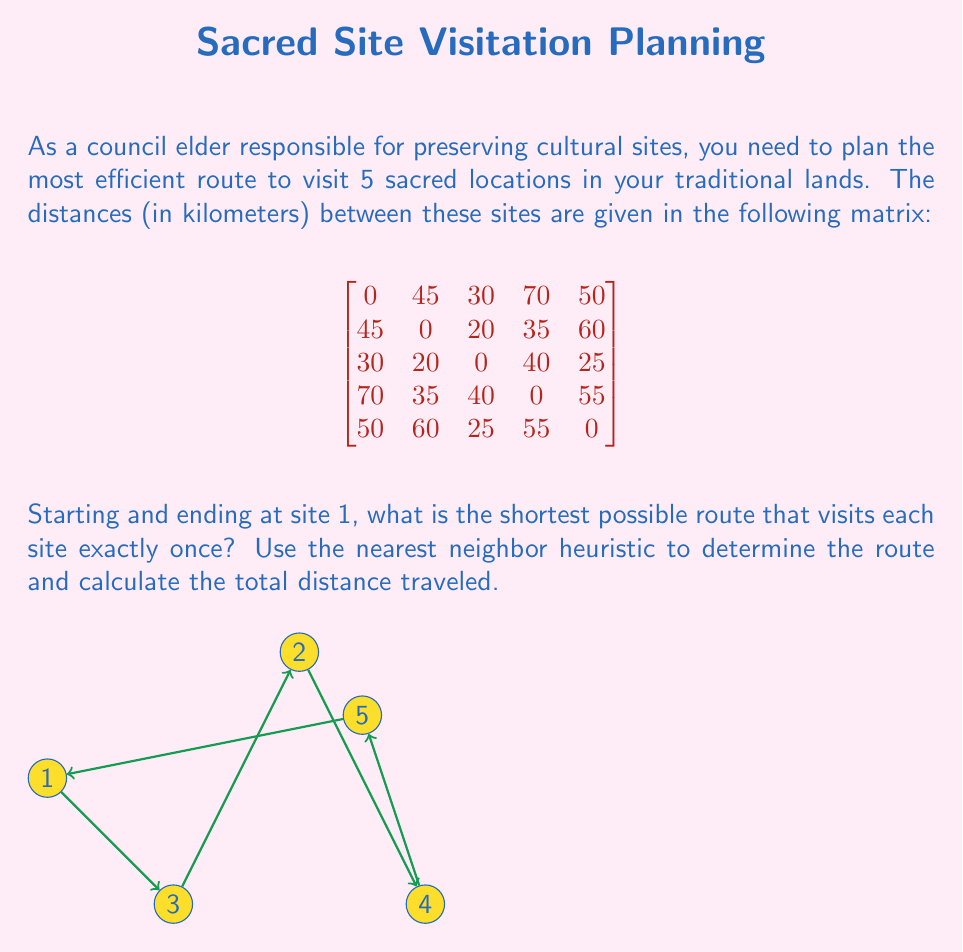Help me with this question. Let's solve this problem using the nearest neighbor heuristic:

1) Start at site 1.

2) Find the nearest unvisited site:
   - From site 1, the nearest is site 3 (30 km).

3) Move to site 3 and repeat:
   - From site 3, the nearest unvisited site is site 2 (20 km).

4) Move to site 2 and repeat:
   - From site 2, the nearest unvisited site is site 4 (35 km).

5) Move to site 4 and repeat:
   - From site 4, the only unvisited site is site 5 (55 km).

6) Move to site 5.

7) Return to site 1 (50 km).

The route is: 1 → 3 → 2 → 4 → 5 → 1

Calculate the total distance:
$$ \text{Total Distance} = 30 + 20 + 35 + 55 + 50 = 190 \text{ km} $$

Note: This heuristic doesn't guarantee the optimal solution, but it provides a good approximation quickly.
Answer: 190 km 